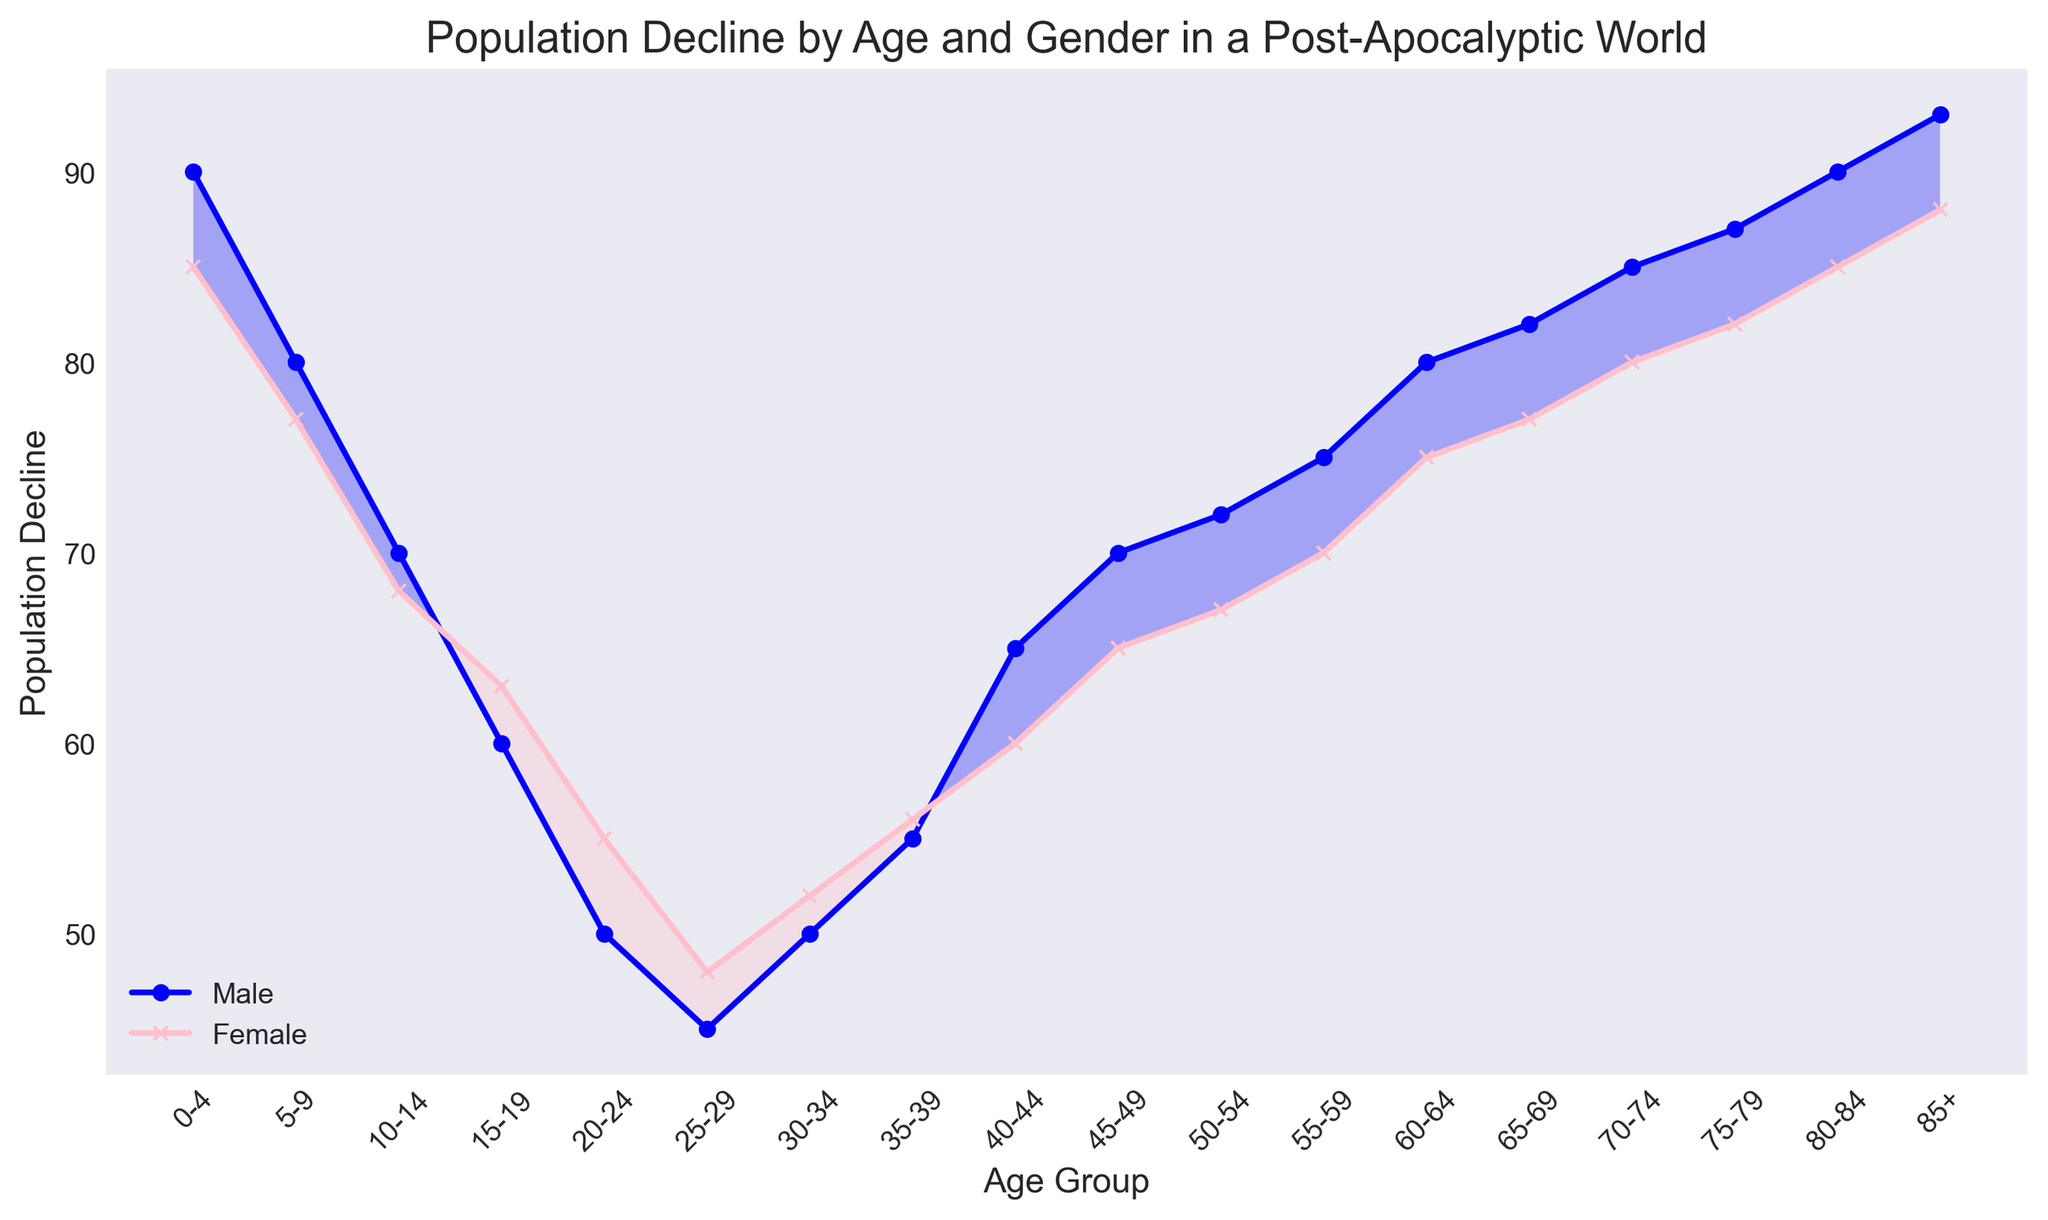Which age group has the highest population decline for males? The age group with the highest population decline for males is the one with the highest value for the male line on the chart. By examining the chart, the male population decline line reaches the peak at the 85+ age group, which is 93.
Answer: 85+ Which age group has the highest population decline for females? The age group with the highest population decline for females is the one with the highest value for the female line on the chart. By examining the chart, the female population decline line reaches the peak at the 85+ age group, which is 88.
Answer: 85+ In which age group is the difference between male and female population decline the greatest? The difference between male and female population decline is greatest where the gap between the two lines is largest. The largest visual gap occurs at the age group 40-44, with males at 65 and females at 60, giving a difference of 5.
Answer: 40-44 Which gender shows a consistently higher population decline in the age range 30-44? To determine which gender shows a consistently higher decline, compare the male and female lines between 30-34, 35-39, and 40-44. For all these age groups, the male population decline is higher than the female population decline.
Answer: Male For the age group 10-14, what is the average population decline? The average population decline for the age group 10-14 is calculated by averaging the male and female population declines: (70 + 68) / 2 = 69.
Answer: 69 Between the age groups 15-19 and 20-24, which age group sees a greater relative decline in population for males? Calculate the difference between the population decline values for each age group for males: 
- For 15-19: 60
- For 20-24: 50
60 - 50 = 10, which means 15-19 sees a greater decline.
Compare the relative decline by (10/60) * 100% = 16.67%.
Answer: 15-19 Which gender has a higher combined population decline in the age groups 45-49 and 50-54? Calculate the combined population decline for each gender:
- Male: 70 (45-49) + 72 (50-54) = 142
- Female: 65 (45-49) + 67 (50-54) = 132
Males have a higher combined population decline.
Answer: Male What is the difference in population decline between males and females in the age group 80-84? Subtract the male population decline from the female in the 80-84 age group: 90 (males) - 85 (females) = 5.
Answer: 5 